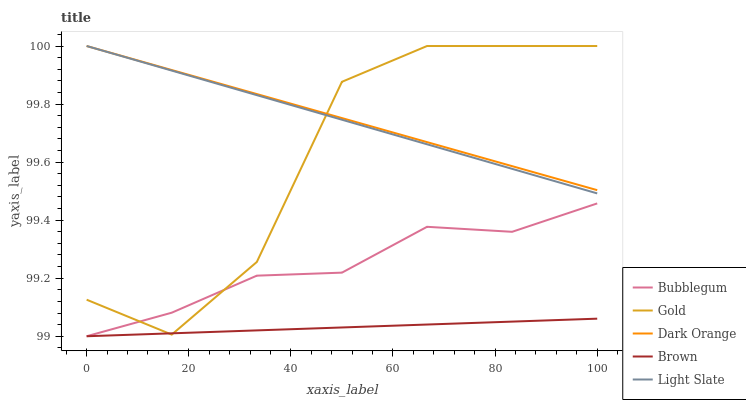Does Brown have the minimum area under the curve?
Answer yes or no. Yes. Does Dark Orange have the maximum area under the curve?
Answer yes or no. Yes. Does Gold have the minimum area under the curve?
Answer yes or no. No. Does Gold have the maximum area under the curve?
Answer yes or no. No. Is Dark Orange the smoothest?
Answer yes or no. Yes. Is Gold the roughest?
Answer yes or no. Yes. Is Gold the smoothest?
Answer yes or no. No. Is Dark Orange the roughest?
Answer yes or no. No. Does Bubblegum have the lowest value?
Answer yes or no. Yes. Does Gold have the lowest value?
Answer yes or no. No. Does Gold have the highest value?
Answer yes or no. Yes. Does Bubblegum have the highest value?
Answer yes or no. No. Is Bubblegum less than Light Slate?
Answer yes or no. Yes. Is Light Slate greater than Bubblegum?
Answer yes or no. Yes. Does Dark Orange intersect Light Slate?
Answer yes or no. Yes. Is Dark Orange less than Light Slate?
Answer yes or no. No. Is Dark Orange greater than Light Slate?
Answer yes or no. No. Does Bubblegum intersect Light Slate?
Answer yes or no. No. 